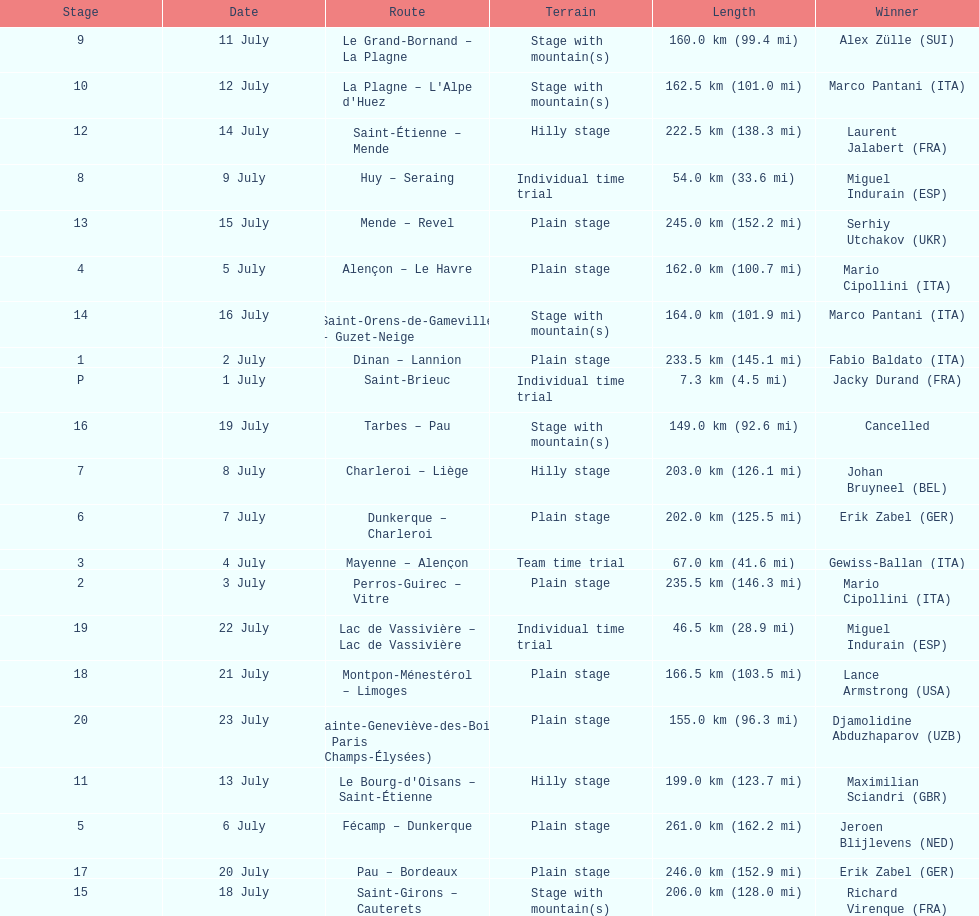How many routes have below 100 km total? 4. 